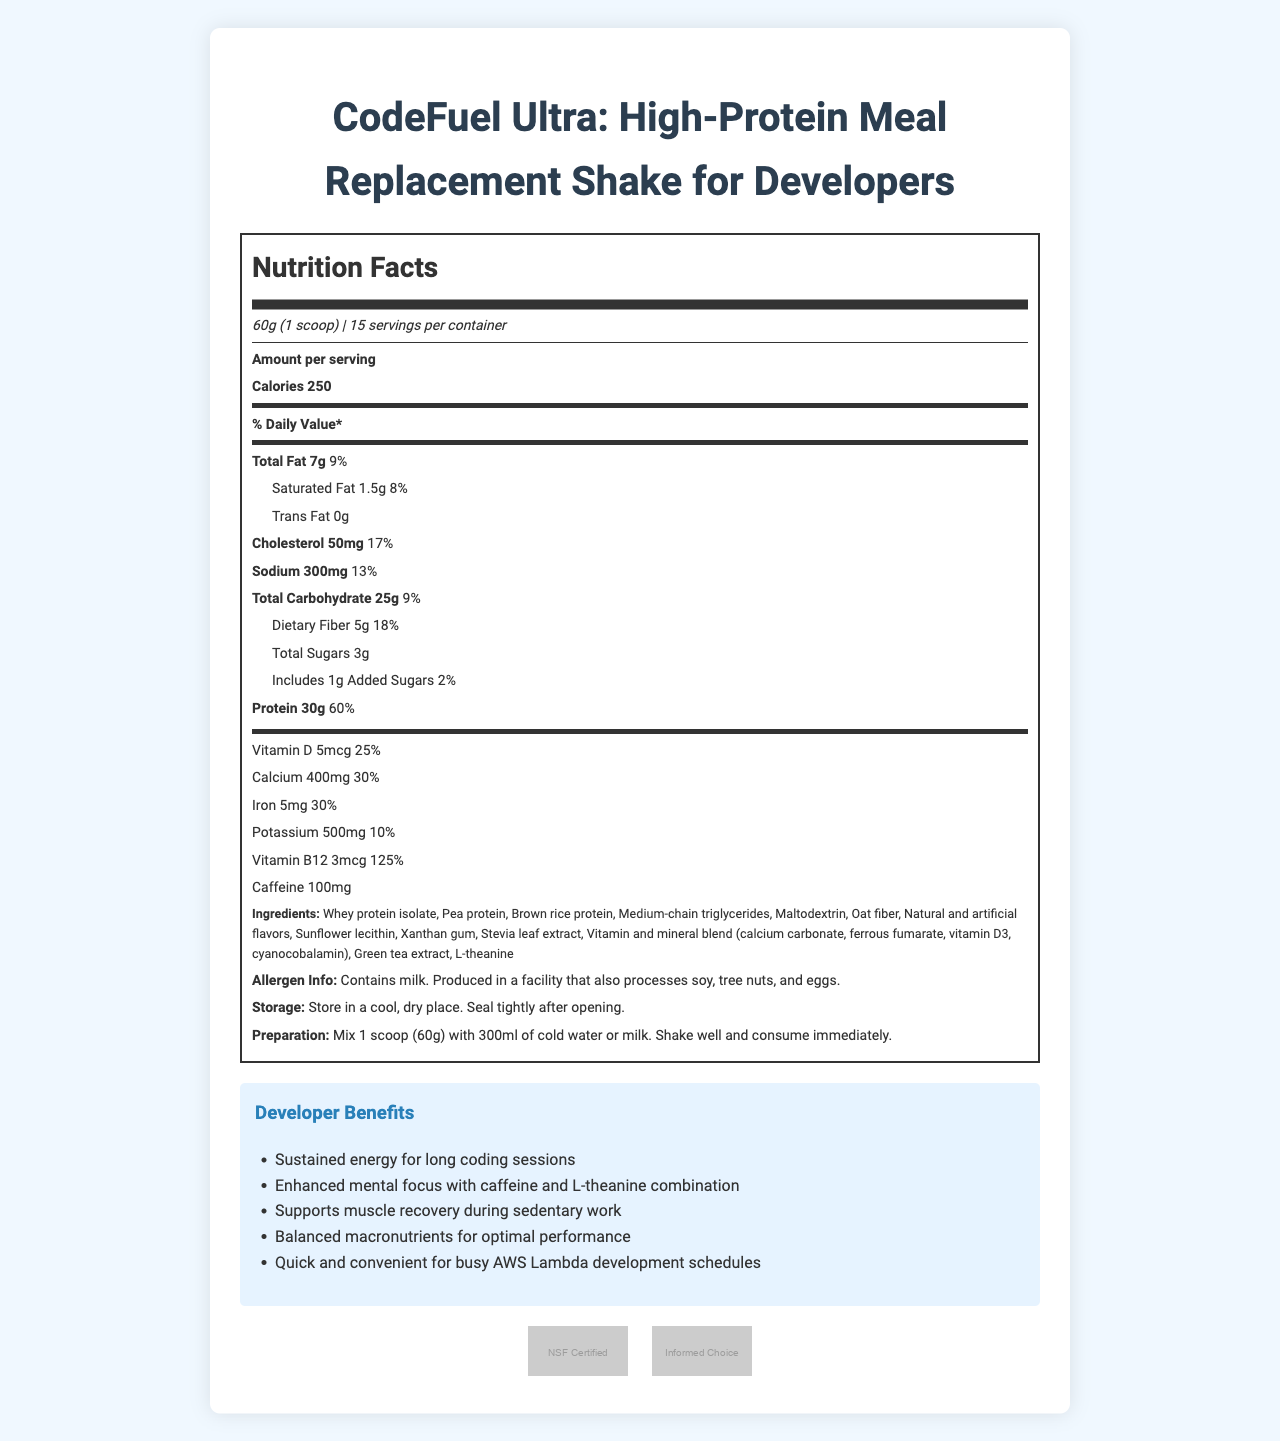what is the product name? The product name is explicitly stated at the top of the document.
Answer: CodeFuel Ultra: High-Protein Meal Replacement Shake for Developers what is the serving size of this product? The serving size information is indicated right below the product name.
Answer: 60g (1 scoop) how many calories are there in each serving? The amount of calories per serving is mentioned clearly in the document.
Answer: 250 how much protein does each serving contain? The protein content per serving is listed as 30g with a daily value of 60%.
Answer: 30g what are the main ingredients of this product? The ingredient list is displayed under the nutrition facts section.
Answer: Whey protein isolate, Pea protein, Brown rice protein, Medium-chain triglycerides, Maltodextrin, Oat fiber, Natural and artificial flavors, Sunflower lecithin, Xanthan gum, Stevia leaf extract, Vitamin and mineral blend (calcium carbonate, ferrous fumarate, vitamin D3, cyanocobalamin), Green tea extract, L-theanine how much caffeine is included per serving? The caffeine content is specified in the data provided.
Answer: 100mg what is the percentage daily value of dietary fiber? The daily value percentage of dietary fiber is displayed as 18%.
Answer: 18% which vitamin has the highest percentage daily value per serving? A. Vitamin D B. Calcium C. Iron D. Vitamin B12 Vitamin B12 has a daily value percentage of 125%, which is higher than the other vitamins and minerals listed.
Answer: D. Vitamin B12 how many total carbohydrates are in a serving? The amount of total carbohydrates per serving is stated as 25g.
Answer: 25g is the product suitable for someone with a soy allergy? The allergen info indicates that the product contains milk and is produced in a facility that processes soy.
Answer: No which certification(s) does the product have? A. NSF Certified for Sport B. Informed-Choice Certified C. USDA Organic D. Both A and B The certifications listed include NSF Certified for Sport and Informed-Choice Certified.
Answer: D. Both A and B can the exact ratio of proteins from whey, pea, and brown rice be determined from this document? The document lists the three proteins but does not provide the specific ratios.
Answer: Not enough information what is the recommended preparation method? The preparation instructions are given in detail in the document.
Answer: Mix 1 scoop (60g) with 300ml of cold water or milk. Shake well and consume immediately. summarize the primary benefits of the product for developers. These benefits are listed in the developer benefits section, making it clear why the product is beneficial for developers.
Answer: The product offers sustained energy for long coding sessions, enhanced mental focus with caffeine and L-theanine combination, supports muscle recovery during sedentary work, provides balanced macronutrients for optimal performance, and is quick and convenient for busy AWS Lambda development schedules. 